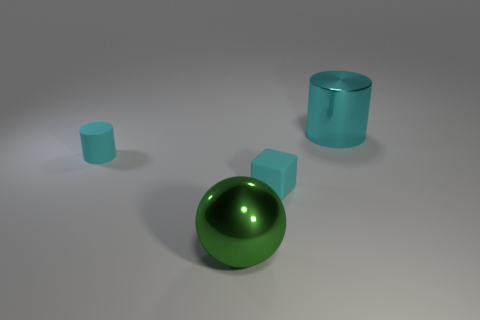Add 2 cyan rubber cylinders. How many objects exist? 6 Subtract 1 cylinders. How many cylinders are left? 1 Subtract 1 cyan cylinders. How many objects are left? 3 Subtract all spheres. How many objects are left? 3 Subtract all blue blocks. Subtract all cyan spheres. How many blocks are left? 1 Subtract all small brown spheres. Subtract all small cyan cylinders. How many objects are left? 3 Add 2 tiny cylinders. How many tiny cylinders are left? 3 Add 1 yellow cubes. How many yellow cubes exist? 1 